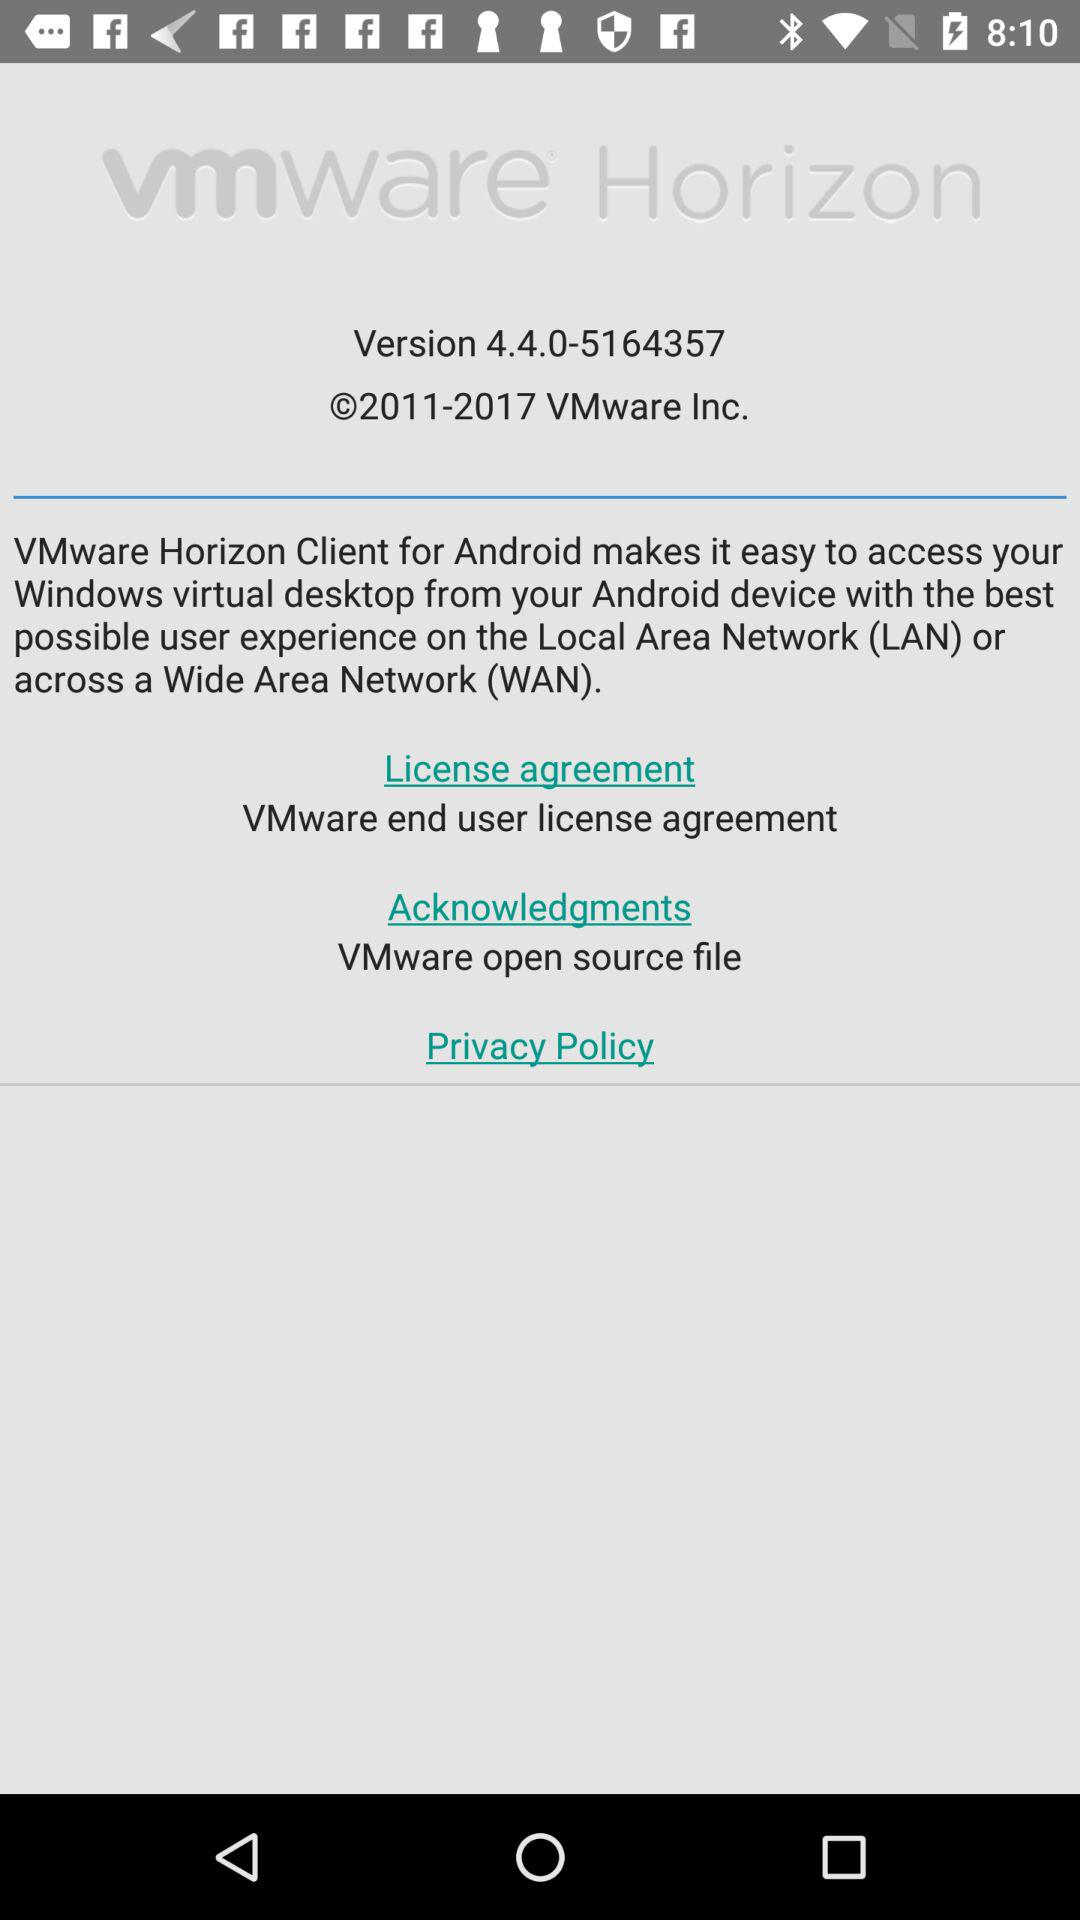What is the application name? The application name is "VMware Horizon". 